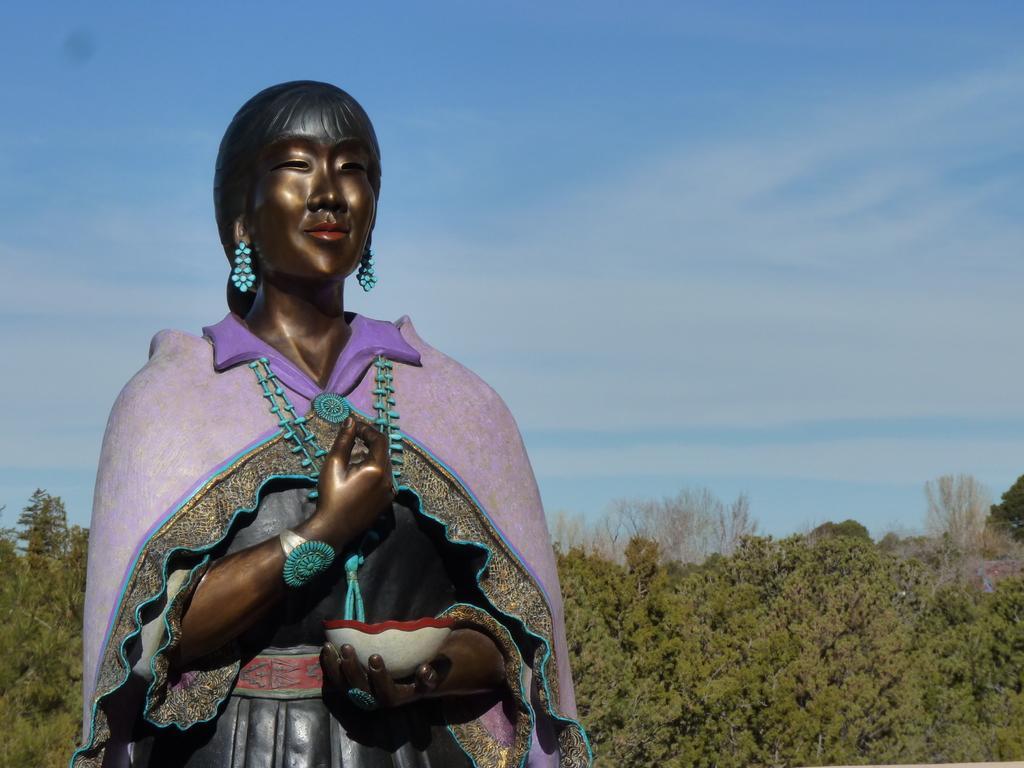How would you summarize this image in a sentence or two? In this image there is a lady sculpture holding bowl behind that there are so many trees. 